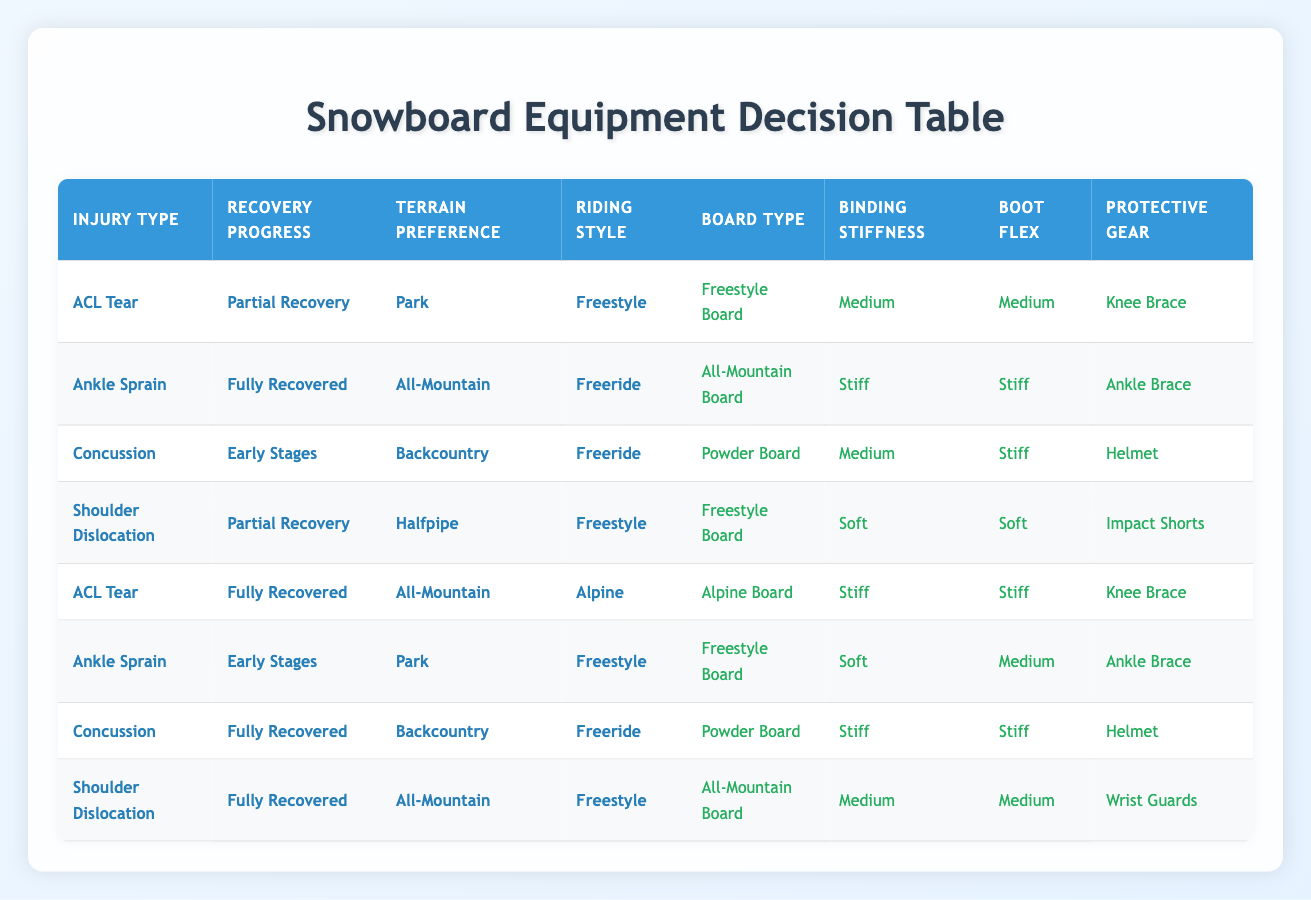What type of board should be used for a Freestyle style with a Shoulder Dislocation in Partial Recovery? The table shows that for a Shoulder Dislocation with Partial Recovery and Freestyle riding style, the recommended board type is a Freestyle Board.
Answer: Freestyle Board What is the appropriate boot flex for someone who has fully recovered from an Ankle Sprain and prefers All-Mountain terrain? According to the table, if someone is fully recovered from an Ankle Sprain and prefers All-Mountain terrain with a Freeride style, the suggested boot flex is Stiff.
Answer: Stiff Is a Knee Brace recommended for someone with an ACL Tear in Partial Recovery? The table indicates that for an ACL Tear in Partial Recovery, a Knee Brace is indeed recommended.
Answer: Yes How many rows in the table feature a Powder Board selection? Reviewing the table, there are two rows that feature a Powder Board: one for Concussion in Early Stages with a Backcountry preference, and another for Concussion in Fully Recovered status with the same preference.
Answer: 2 If a snowboarder with an Ankle Sprain in the Early Stages prefers Freestyle and Park, what binding stiffness is recommended? The table indicates that for an Ankle Sprain in Early Stages with Freestyle riding style and Park terrain preference, the recommended binding stiffness is Soft.
Answer: Soft What is the recommended protective gear for a Fully Recovered Shoulder Dislocation riding Freestyle on All-Mountain terrain? The table indicates that for a Fully Recovered Shoulder Dislocation riding Freestyle in All-Mountain terrain, the recommended protective gear is Wrist Guards.
Answer: Wrist Guards How does the recommended board type differ between an ACL Tear in Fully Recovered status riding All-Mountain with an Alpine style and an Ankle Sprain in Fully Recovered status riding All-Mountain with Freeride style? Comparing both conditions, the ACL Tear in Fully Recovered status suggests an Alpine Board, while the Ankle Sprain in Fully Recovered status recommends an All-Mountain Board. Therefore, the difference in board types is Alpine Board vs. All-Mountain Board.
Answer: Alpine Board vs. All-Mountain Board What is the average binding stiffness for snowboarders recovering from an ACL Tear? Looking at the rows for ACL Tear, we have two instances: one with Medium stiffness for Partial Recovery and one with Stiff stiffness for Fully Recovered. Therefore, the average is (Medium + Stiff) / 2. Assigning values (Medium = 1, Stiff = 2), we get (1 + 2) / 2 = 1.5, which corresponds to Medium.
Answer: Medium 